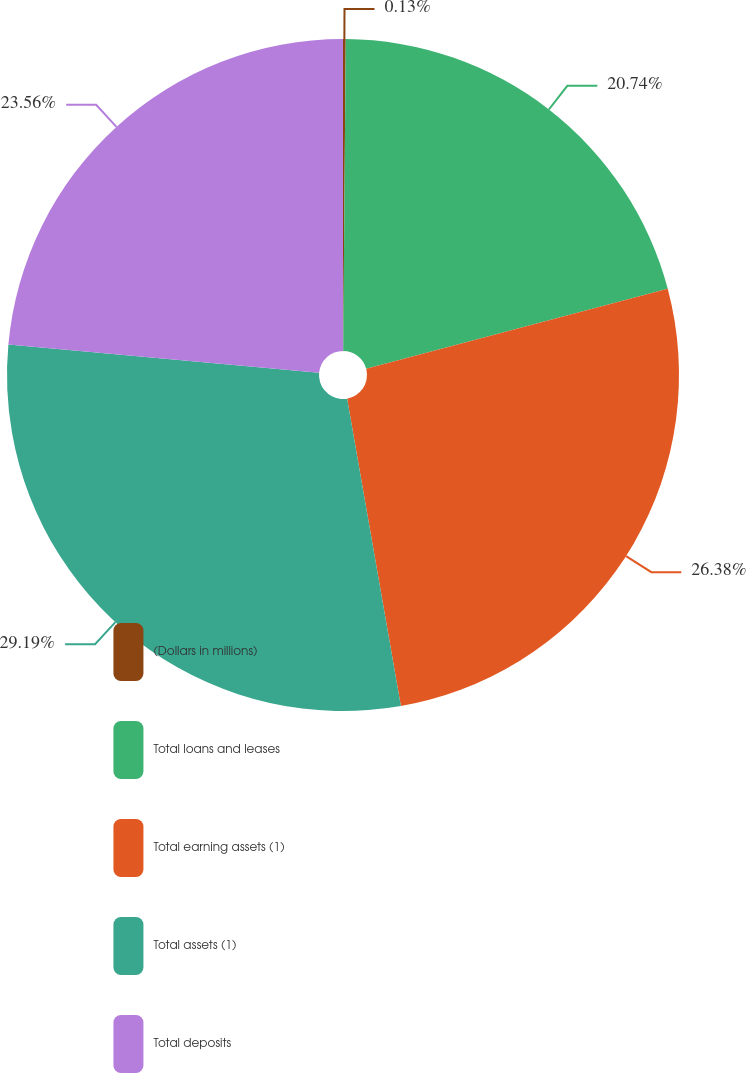Convert chart to OTSL. <chart><loc_0><loc_0><loc_500><loc_500><pie_chart><fcel>(Dollars in millions)<fcel>Total loans and leases<fcel>Total earning assets (1)<fcel>Total assets (1)<fcel>Total deposits<nl><fcel>0.13%<fcel>20.74%<fcel>26.38%<fcel>29.2%<fcel>23.56%<nl></chart> 